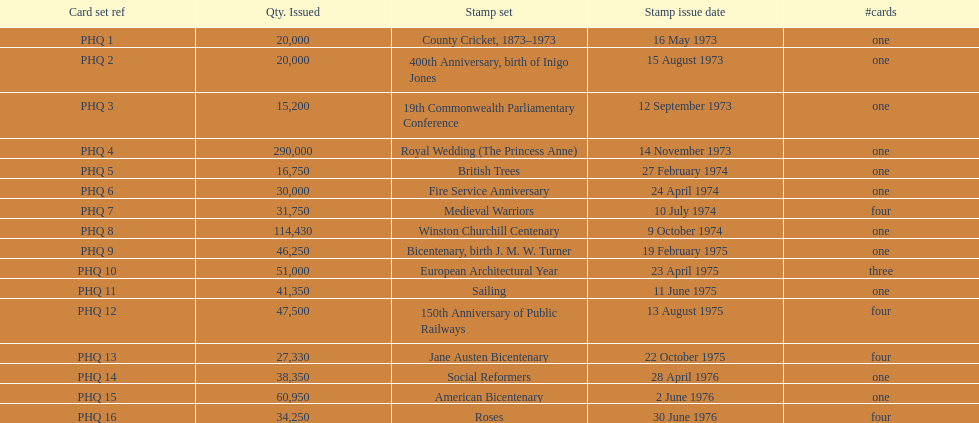Which card was issued most? Royal Wedding (The Princess Anne). 